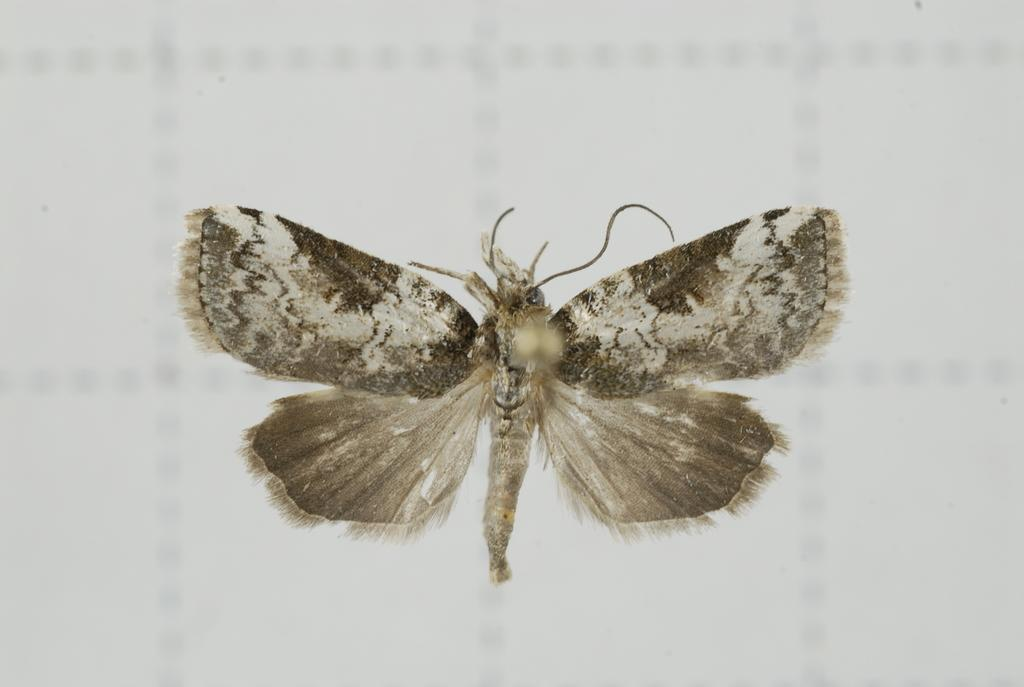What is the main subject of the picture? The main subject of the picture is a moth. What color is the background of the picture? The background of the picture is white. Is the moth wearing a veil in the image? There is no indication in the image that the moth is wearing a veil. What is the temper of the rabbit in the image? There is no rabbit present in the image, so it is not possible to determine its temper. 